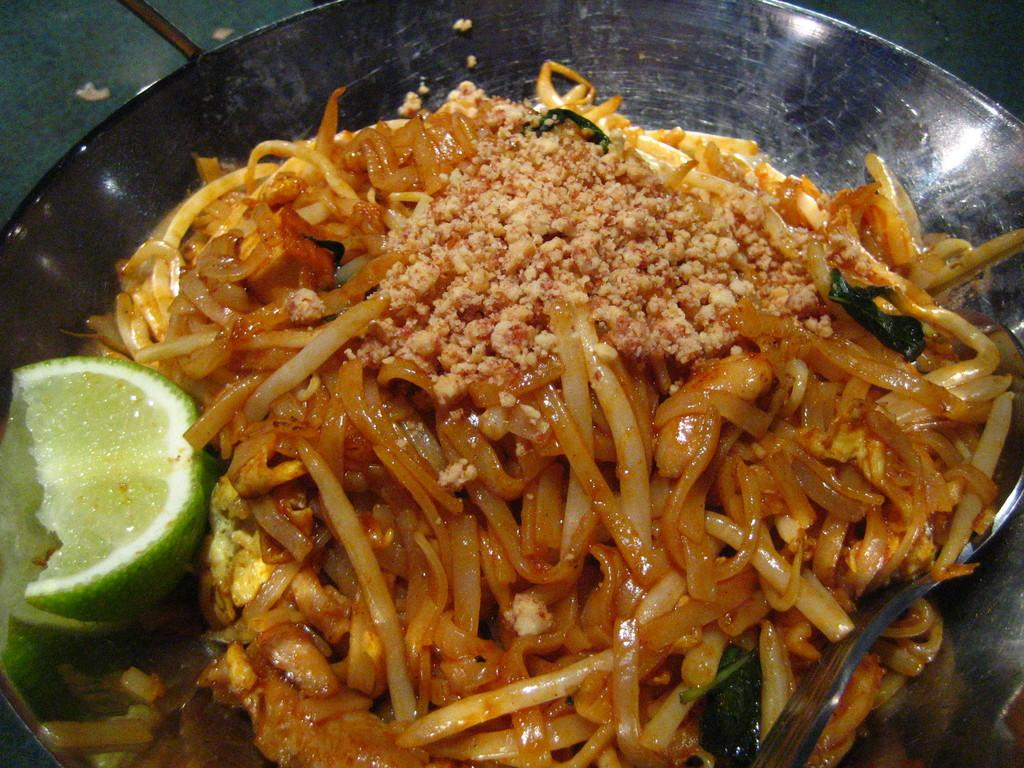What type of food can be seen in the image? There is food in the image, but the specific type is not mentioned. What is placed on top of the food in the image? There is a lemon slice in the image. What utensil is present in the image? There is a spoon in the image. What type of bowl is visible in the image? The silver bowl is present in the image. What type of cushion is used to support the quill in the image? There is no cushion or quill present in the image. 